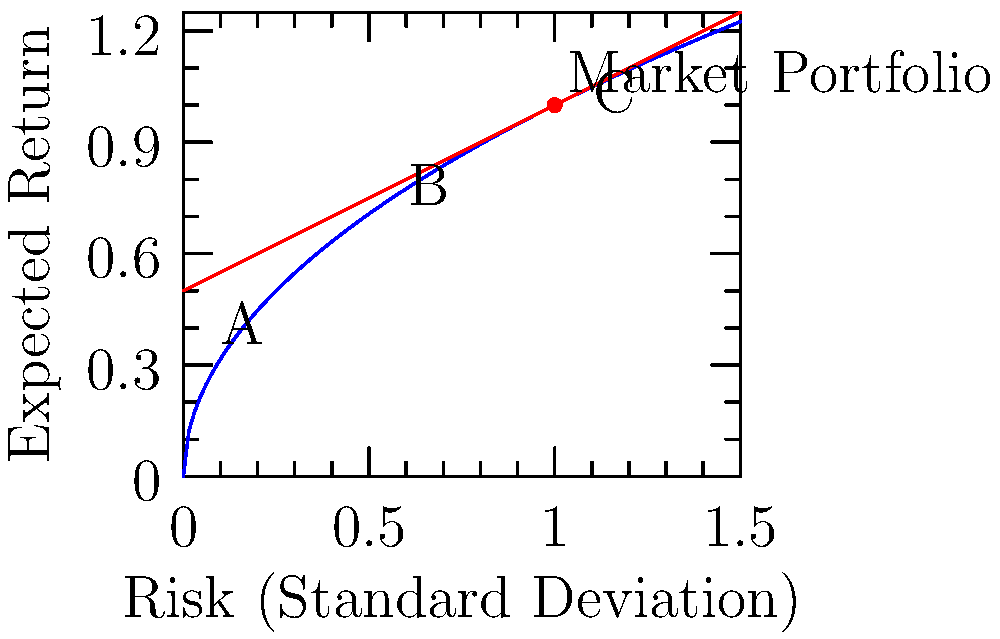Based on the efficient frontier graph and capital market line shown, which point (A, B, or C) represents the optimal portfolio for an investor seeking to maximize the Sharpe ratio? To determine the optimal portfolio that maximizes the Sharpe ratio, we need to follow these steps:

1. Understand the graph:
   - The blue curve represents the efficient frontier.
   - The red line represents the Capital Market Line (CML).
   - The point where the CML touches the efficient frontier is the Market Portfolio.

2. Recall that the Sharpe ratio is defined as:
   $$ \text{Sharpe Ratio} = \frac{R_p - R_f}{\sigma_p} $$
   Where $R_p$ is the portfolio return, $R_f$ is the risk-free rate, and $\sigma_p$ is the portfolio standard deviation.

3. The CML represents portfolios with the highest Sharpe ratio for any given level of risk.

4. The tangency point between the CML and the efficient frontier (the Market Portfolio) represents the optimal risky portfolio that maximizes the Sharpe ratio.

5. Examine the given points:
   - Point A is below the CML and on the efficient frontier.
   - Point B is on the CML but not at the tangency point.
   - Point C is on the CML but not at the tangency point.

6. The Market Portfolio, which is the tangency point between the CML and the efficient frontier, is located at (1,1) on the graph.

7. Among the given options, point B is closest to the Market Portfolio and lies on the CML.

Therefore, point B represents the optimal portfolio that maximizes the Sharpe ratio among the given choices.
Answer: B 